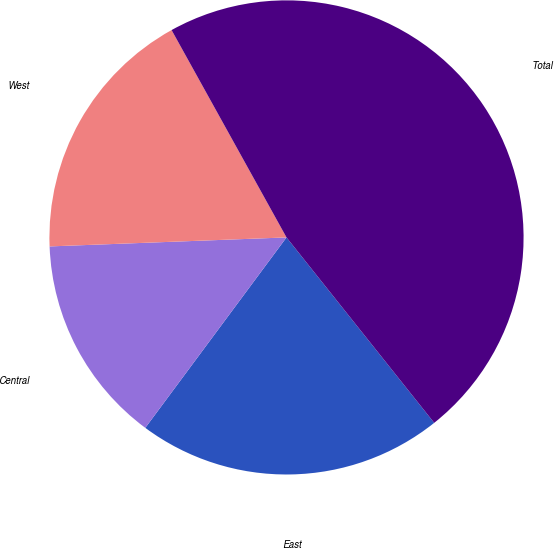Convert chart. <chart><loc_0><loc_0><loc_500><loc_500><pie_chart><fcel>East<fcel>Central<fcel>West<fcel>Total<nl><fcel>20.86%<fcel>14.24%<fcel>17.55%<fcel>47.35%<nl></chart> 